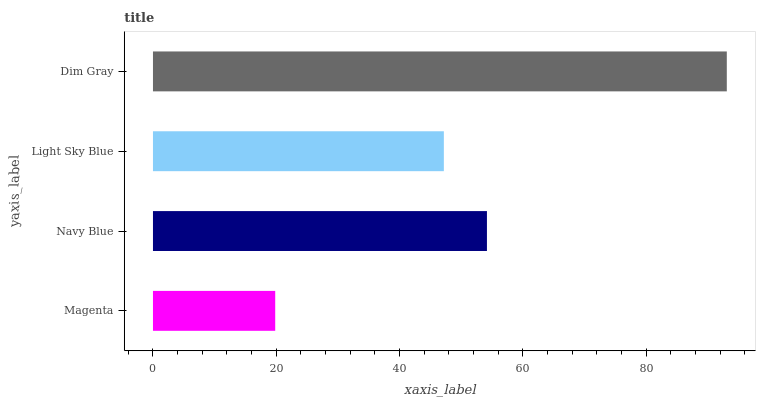Is Magenta the minimum?
Answer yes or no. Yes. Is Dim Gray the maximum?
Answer yes or no. Yes. Is Navy Blue the minimum?
Answer yes or no. No. Is Navy Blue the maximum?
Answer yes or no. No. Is Navy Blue greater than Magenta?
Answer yes or no. Yes. Is Magenta less than Navy Blue?
Answer yes or no. Yes. Is Magenta greater than Navy Blue?
Answer yes or no. No. Is Navy Blue less than Magenta?
Answer yes or no. No. Is Navy Blue the high median?
Answer yes or no. Yes. Is Light Sky Blue the low median?
Answer yes or no. Yes. Is Light Sky Blue the high median?
Answer yes or no. No. Is Magenta the low median?
Answer yes or no. No. 